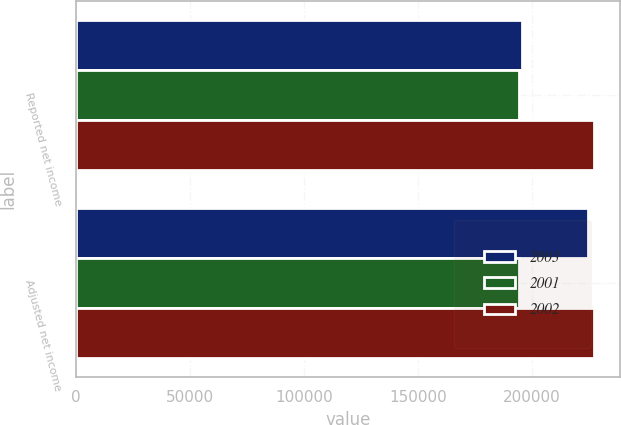Convert chart. <chart><loc_0><loc_0><loc_500><loc_500><stacked_bar_chart><ecel><fcel>Reported net income<fcel>Adjusted net income<nl><fcel>2003<fcel>195868<fcel>224789<nl><fcel>2001<fcel>194254<fcel>194254<nl><fcel>2002<fcel>227487<fcel>227487<nl></chart> 